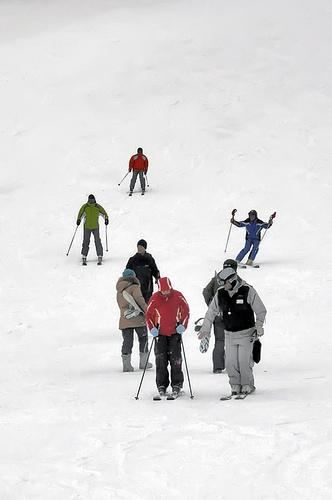What is the man in grey pants doing? Please explain your reasoning. coaching. He is walking with the skiiers. 